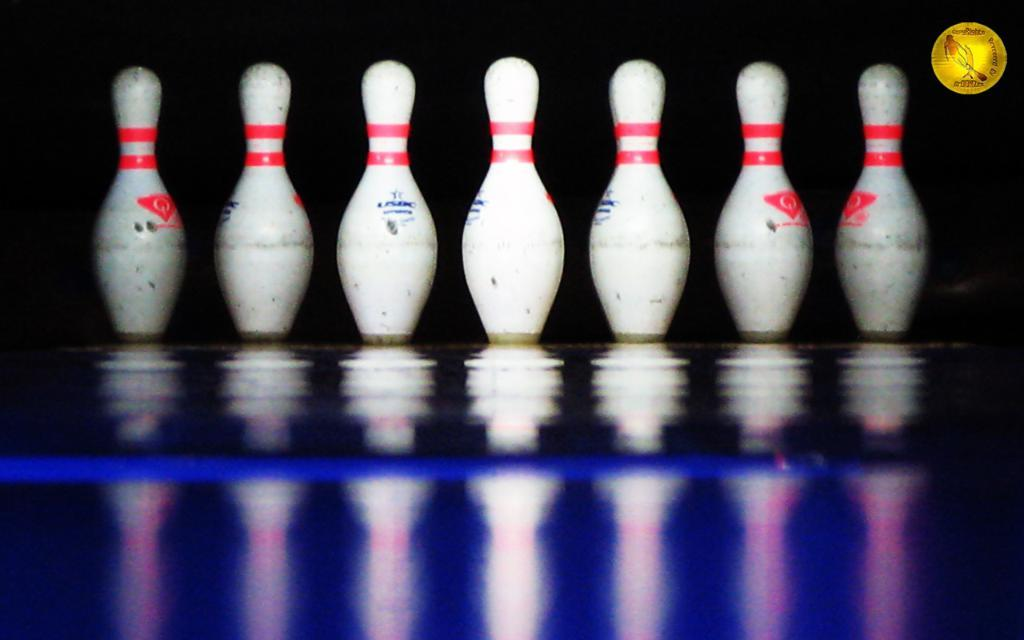What objects are on the floor in the image? There are bowling pins on the floor. Can you describe the floor in the image? The floor has a reflection of the bowling pins. What type of learning material can be seen on the floor in the image? There is no learning material present in the image; it features bowling pins on the floor. What type of soap is visible in the image? There is no soap present in the image. 